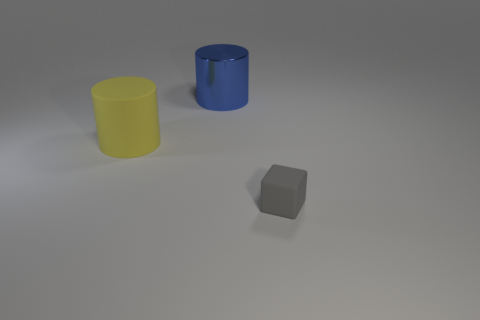Add 3 big yellow rubber objects. How many objects exist? 6 Subtract all cylinders. How many objects are left? 1 Subtract all small gray metallic things. Subtract all cylinders. How many objects are left? 1 Add 2 tiny gray blocks. How many tiny gray blocks are left? 3 Add 2 small brown rubber objects. How many small brown rubber objects exist? 2 Subtract 0 purple balls. How many objects are left? 3 